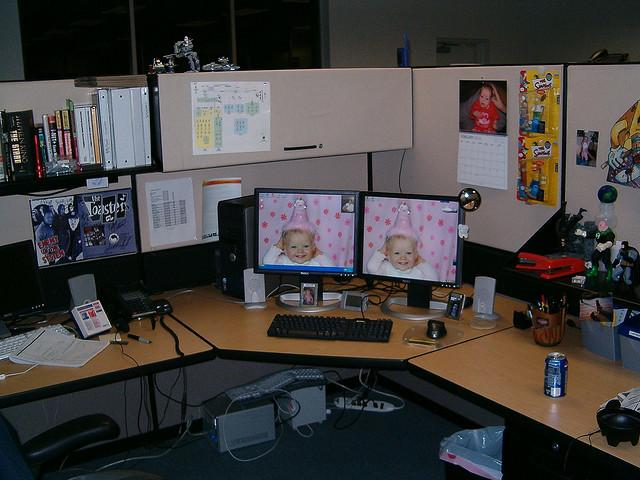Where is this desk setup? office 